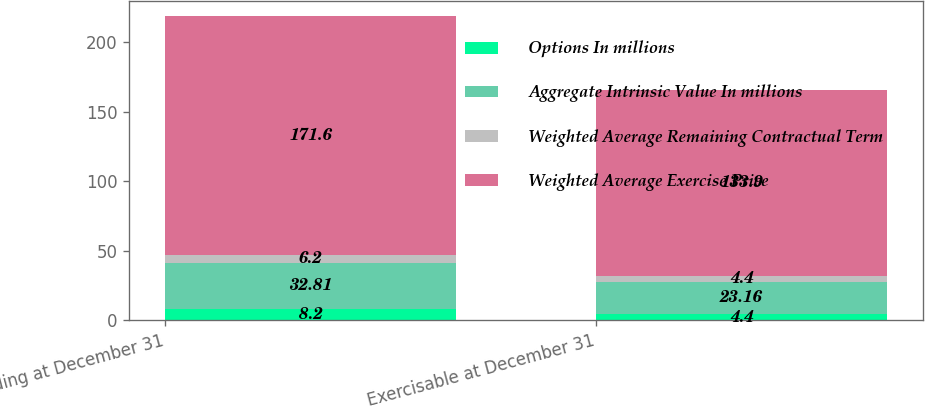Convert chart. <chart><loc_0><loc_0><loc_500><loc_500><stacked_bar_chart><ecel><fcel>Outstanding at December 31<fcel>Exercisable at December 31<nl><fcel>Options In millions<fcel>8.2<fcel>4.4<nl><fcel>Aggregate Intrinsic Value In millions<fcel>32.81<fcel>23.16<nl><fcel>Weighted Average Remaining Contractual Term<fcel>6.2<fcel>4.4<nl><fcel>Weighted Average Exercise Price<fcel>171.6<fcel>133.9<nl></chart> 